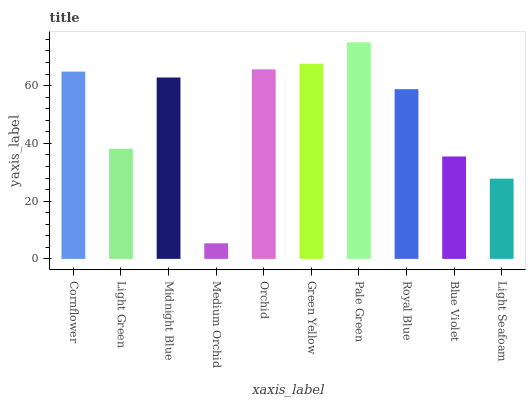Is Light Green the minimum?
Answer yes or no. No. Is Light Green the maximum?
Answer yes or no. No. Is Cornflower greater than Light Green?
Answer yes or no. Yes. Is Light Green less than Cornflower?
Answer yes or no. Yes. Is Light Green greater than Cornflower?
Answer yes or no. No. Is Cornflower less than Light Green?
Answer yes or no. No. Is Midnight Blue the high median?
Answer yes or no. Yes. Is Royal Blue the low median?
Answer yes or no. Yes. Is Light Seafoam the high median?
Answer yes or no. No. Is Blue Violet the low median?
Answer yes or no. No. 